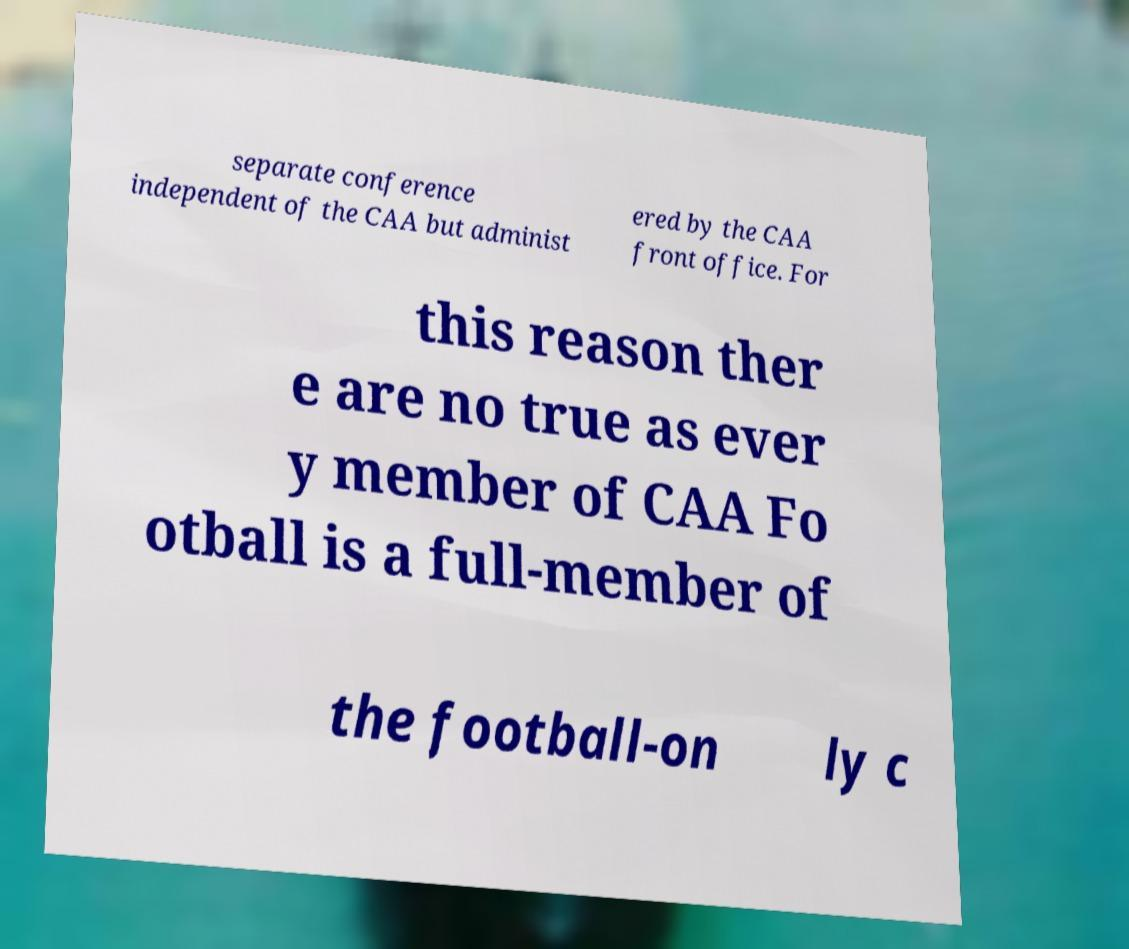Could you assist in decoding the text presented in this image and type it out clearly? separate conference independent of the CAA but administ ered by the CAA front office. For this reason ther e are no true as ever y member of CAA Fo otball is a full-member of the football-on ly c 